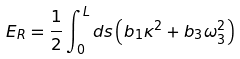<formula> <loc_0><loc_0><loc_500><loc_500>E _ { R } = \frac { 1 } { 2 } \int \nolimits _ { 0 } ^ { L } d s \left ( b _ { 1 } \kappa ^ { 2 } + b _ { 3 } \omega _ { 3 } ^ { 2 } \right )</formula> 